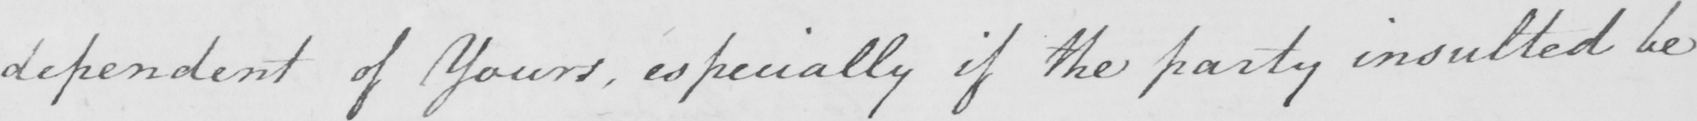What is written in this line of handwriting? dependent of Yours , especially if the party insulted be 